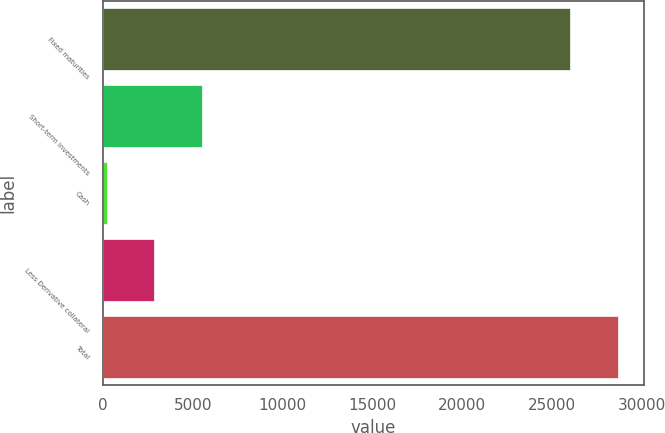Convert chart. <chart><loc_0><loc_0><loc_500><loc_500><bar_chart><fcel>Fixed maturities<fcel>Short-term investments<fcel>Cash<fcel>Less Derivative collateral<fcel>Total<nl><fcel>26034<fcel>5497<fcel>203<fcel>2850<fcel>28681<nl></chart> 